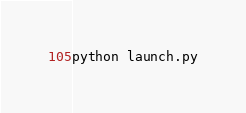Convert code to text. <code><loc_0><loc_0><loc_500><loc_500><_Bash_>python launch.py
</code> 